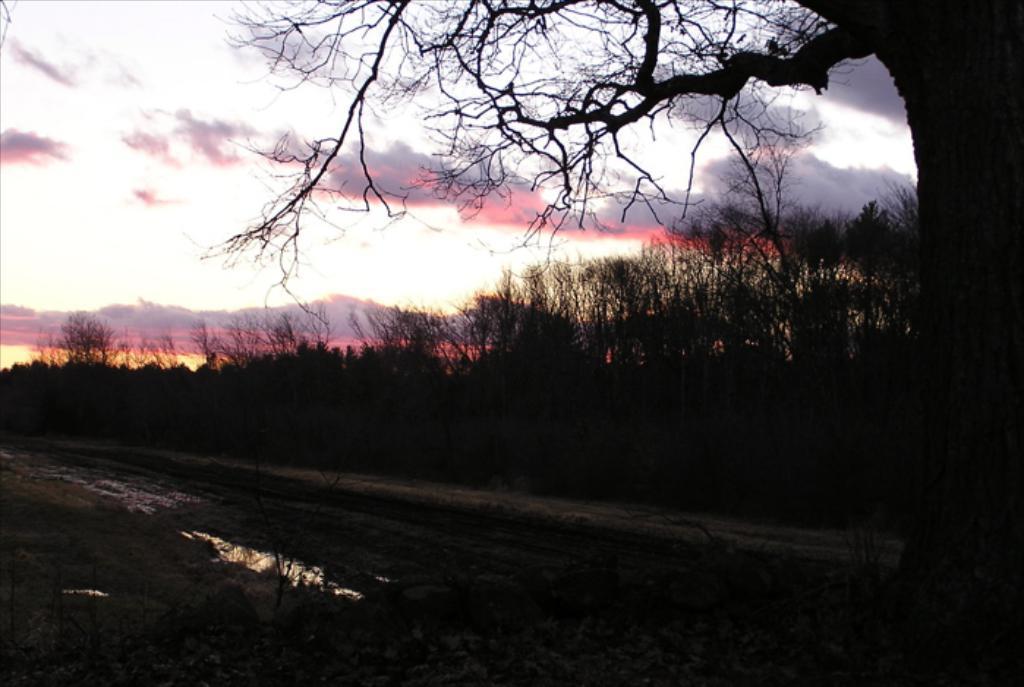Please provide a concise description of this image. In this image we can see some plants, trees and water. On the backside we can see the hills and the sky which looks cloudy. 